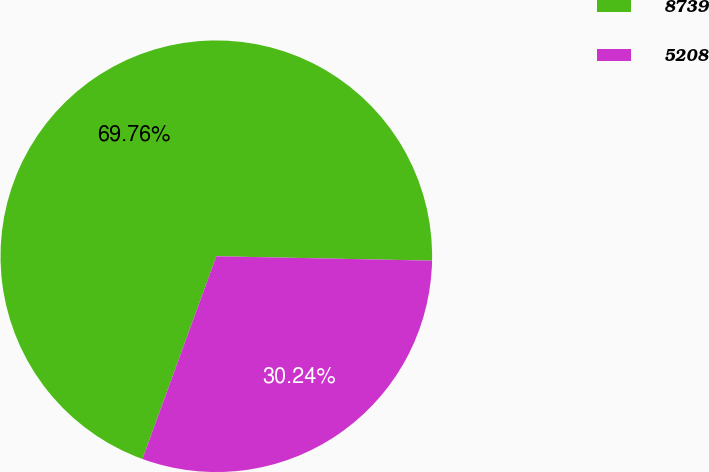<chart> <loc_0><loc_0><loc_500><loc_500><pie_chart><fcel>8739<fcel>5208<nl><fcel>69.76%<fcel>30.24%<nl></chart> 